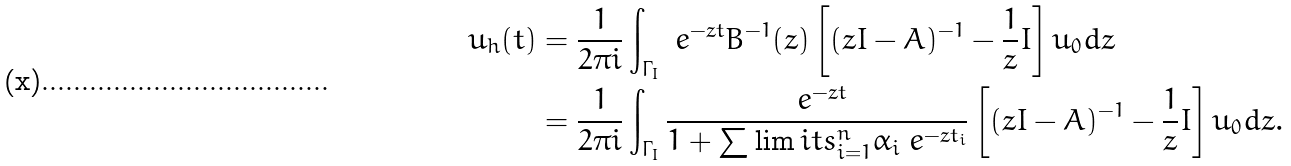<formula> <loc_0><loc_0><loc_500><loc_500>u _ { h } ( t ) & = \frac { 1 } { 2 \pi i } \int _ { \Gamma _ { I } } \ e ^ { - z t } B ^ { - 1 } ( z ) \left [ ( z I - A ) ^ { - 1 } - \frac { 1 } { z } I \right ] u _ { 0 } d z \\ & = \frac { 1 } { 2 \pi i } \int _ { \Gamma _ { I } } \frac { \ e ^ { - z t } } { 1 + \sum \lim i t s _ { i = 1 } ^ { n } \alpha _ { i } \ e ^ { - z t _ { i } } } \left [ ( z I - A ) ^ { - 1 } - \frac { 1 } { z } I \right ] u _ { 0 } d z .</formula> 